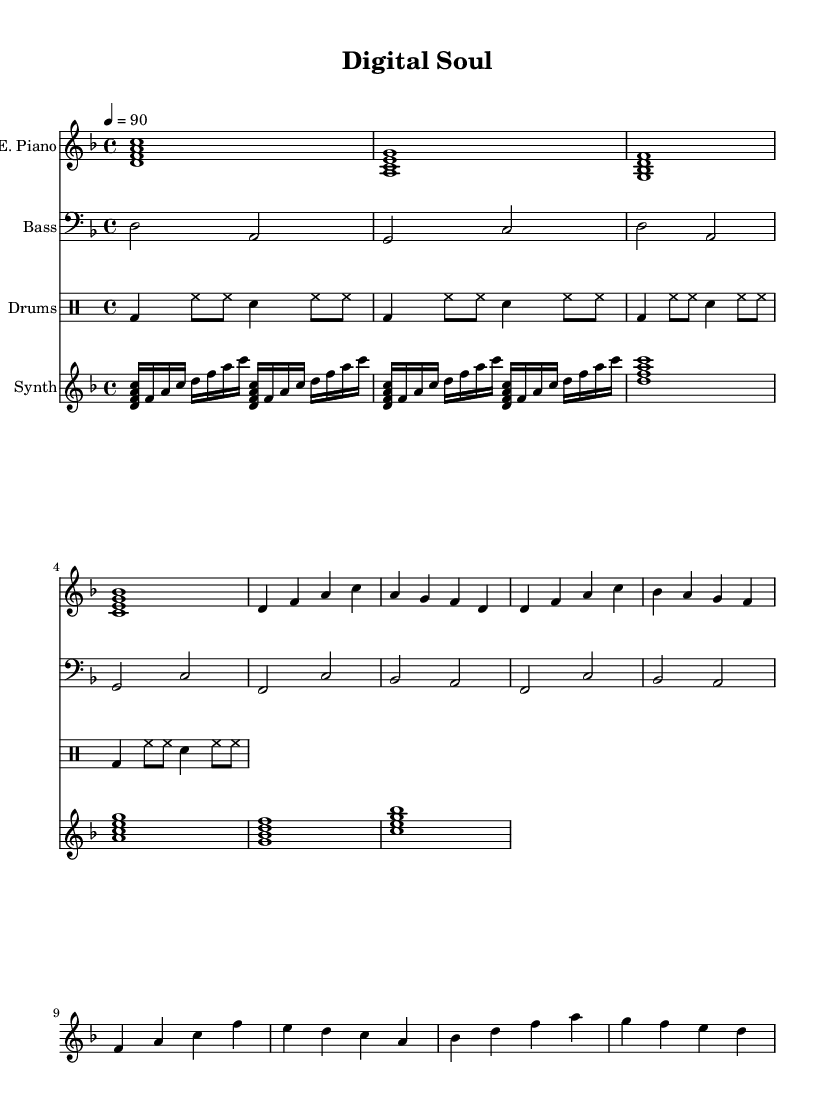What is the key signature of this music? The key signature is D minor, which has one flat (B flat). It is determined by the key indicated next to the global block in the code.
Answer: D minor What is the time signature of this piece? The time signature is 4/4, signifying four beats per measure. This is explicitly stated in the global block of the code.
Answer: 4/4 What is the tempo of the piece? The tempo indicated is quarter note equals 90 beats per minute. This is found in the tempo marking within the global block.
Answer: 90 How many measures are in the chorus? The chorus contains four measures. By examining the portion of the score designated for the chorus, we can see there are four distinct measures.
Answer: 4 What type of musical instrument is the main melodic part played on? The main melodic part is played on an electric piano, as labelled in the score. This is noted at the beginning of the electric piano staff.
Answer: Electric Piano Which chord progression is used in the verse? The chord progression in the verse is D minor, A minor, G minor, B flat major. This can be deduced by analyzing the chords listed in the verse section of the electric piano line.
Answer: D minor, A minor, G minor, B flat major What theme does this piece explore? This piece explores themes of technological advancement, as inferred from the title "Digital Soul" and the stylistic elements typical of contemporary neo-soul.
Answer: Technological advancement 